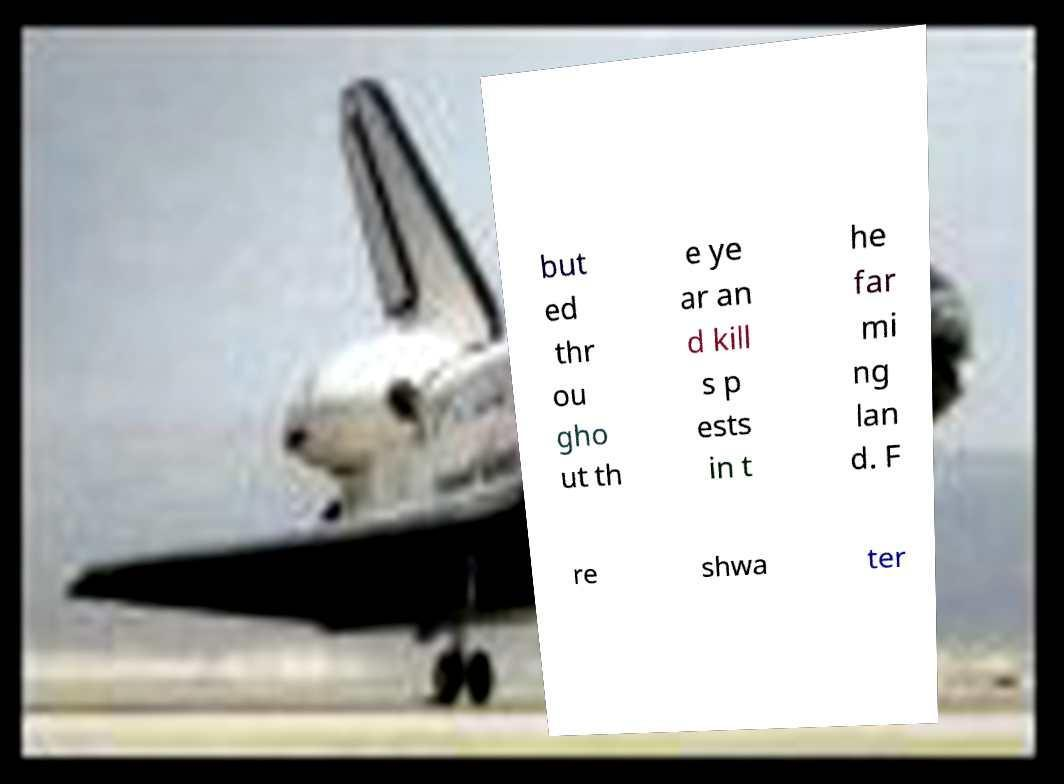I need the written content from this picture converted into text. Can you do that? but ed thr ou gho ut th e ye ar an d kill s p ests in t he far mi ng lan d. F re shwa ter 